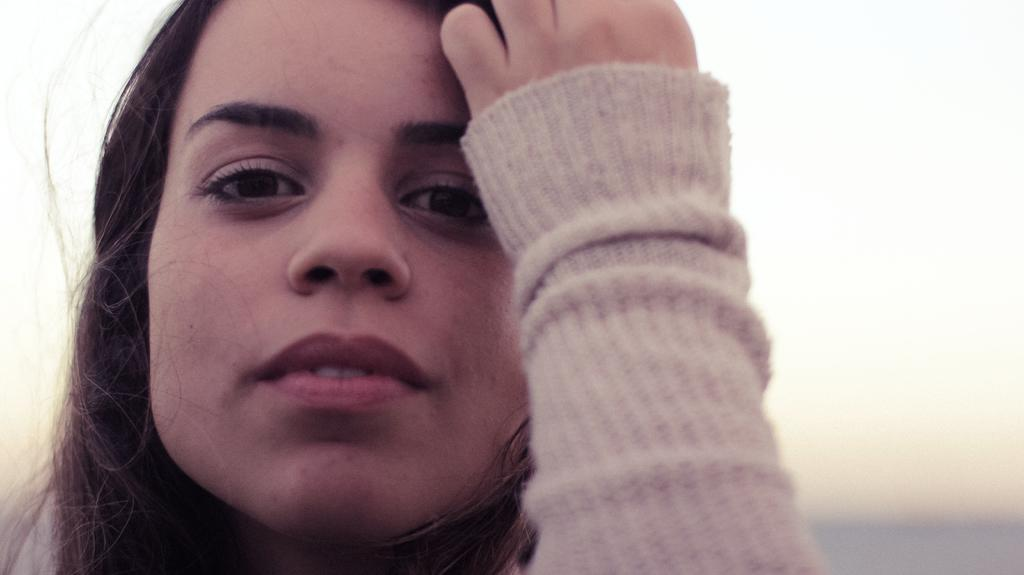What is the main subject of the image? The main subject of the image is a person's face. Where is the person's face located in the image? The person's face is on the left side of the image. What can be seen in the background of the image? There is a sky visible in the background of the image. What type of dress is the visitor wearing in the image? There is no visitor present in the image, and therefore no dress can be observed. 